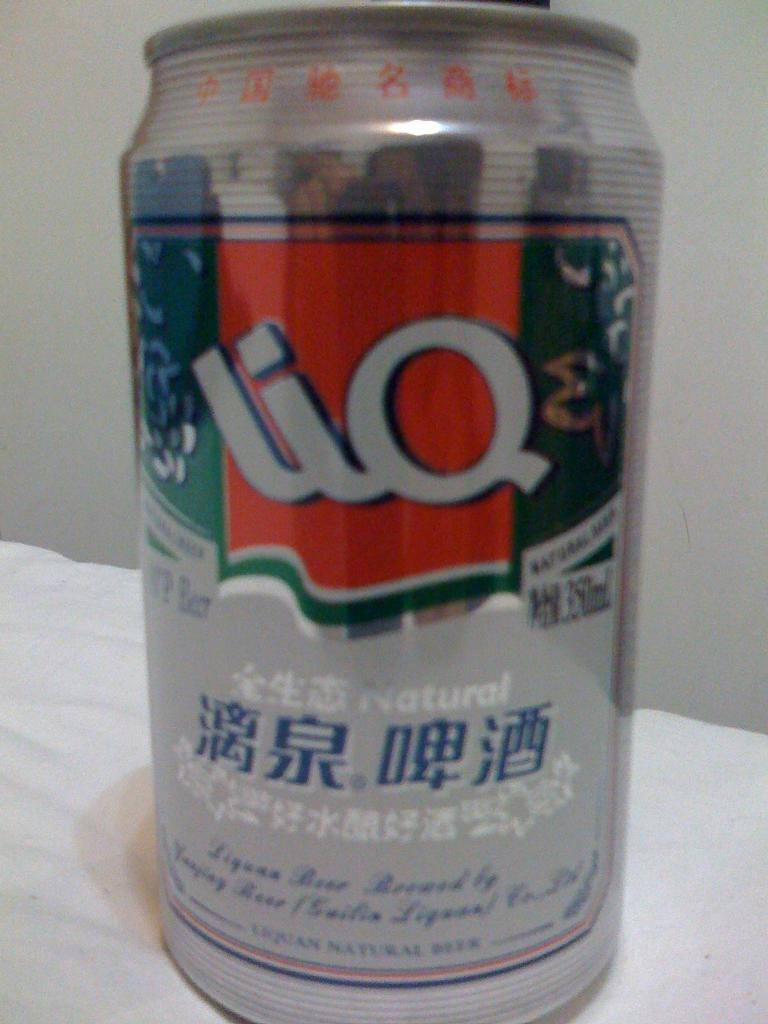Provide a one-sentence caption for the provided image. a Lio can that is on a white surface. 